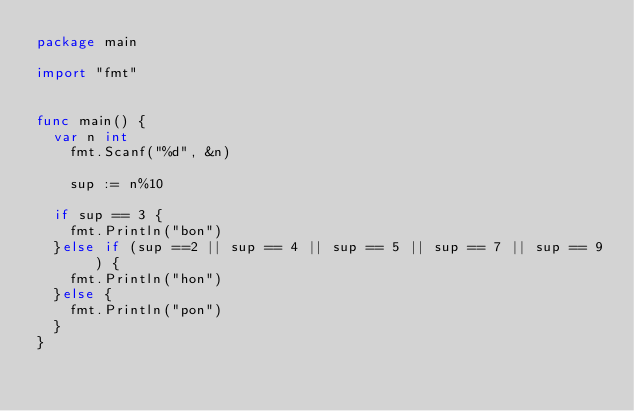<code> <loc_0><loc_0><loc_500><loc_500><_Go_>package main

import "fmt"


func main() {
	var n int
  	fmt.Scanf("%d", &n)
  	
  	sup := n%10
  
  if sup == 3 {
    fmt.Println("bon")
  }else if (sup ==2 || sup == 4 || sup == 5 || sup == 7 || sup == 9 ) {
    fmt.Println("hon")
  }else {
    fmt.Println("pon")
  }
}</code> 